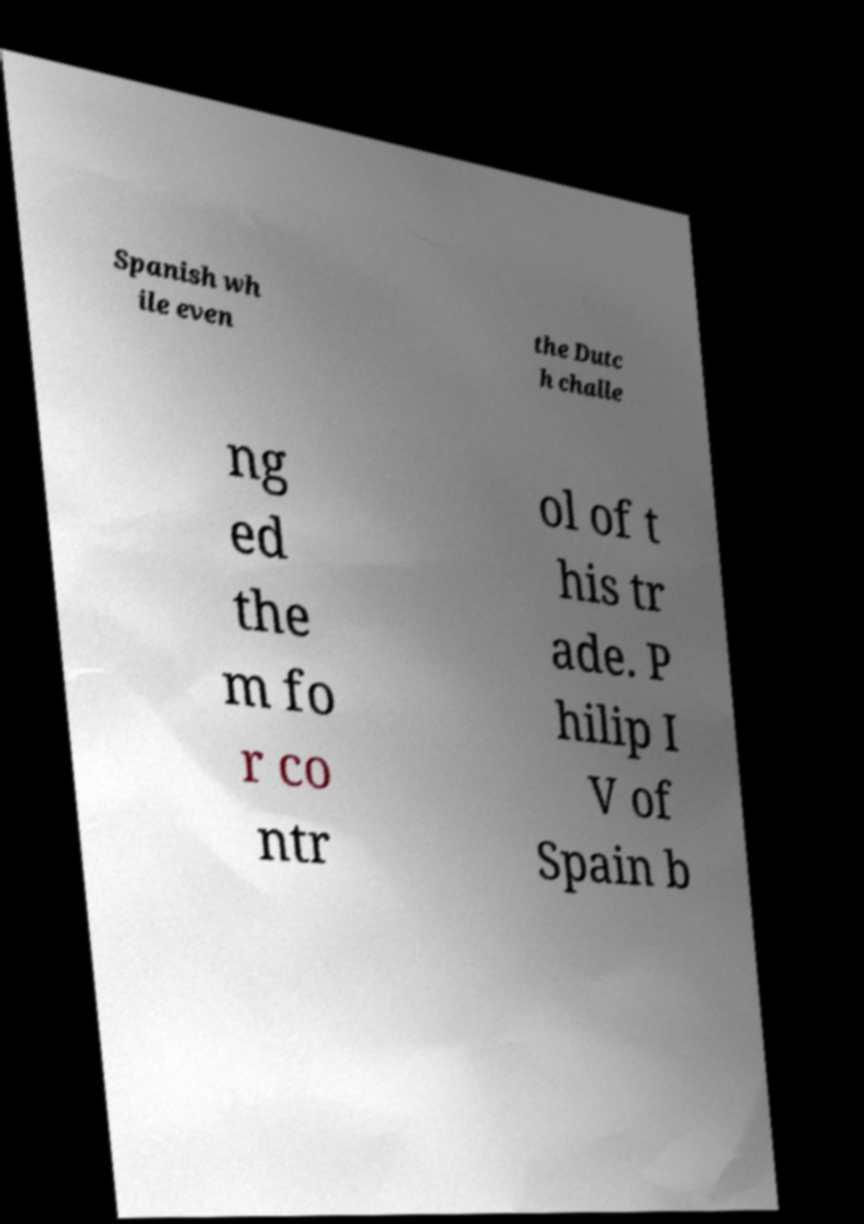I need the written content from this picture converted into text. Can you do that? Spanish wh ile even the Dutc h challe ng ed the m fo r co ntr ol of t his tr ade. P hilip I V of Spain b 